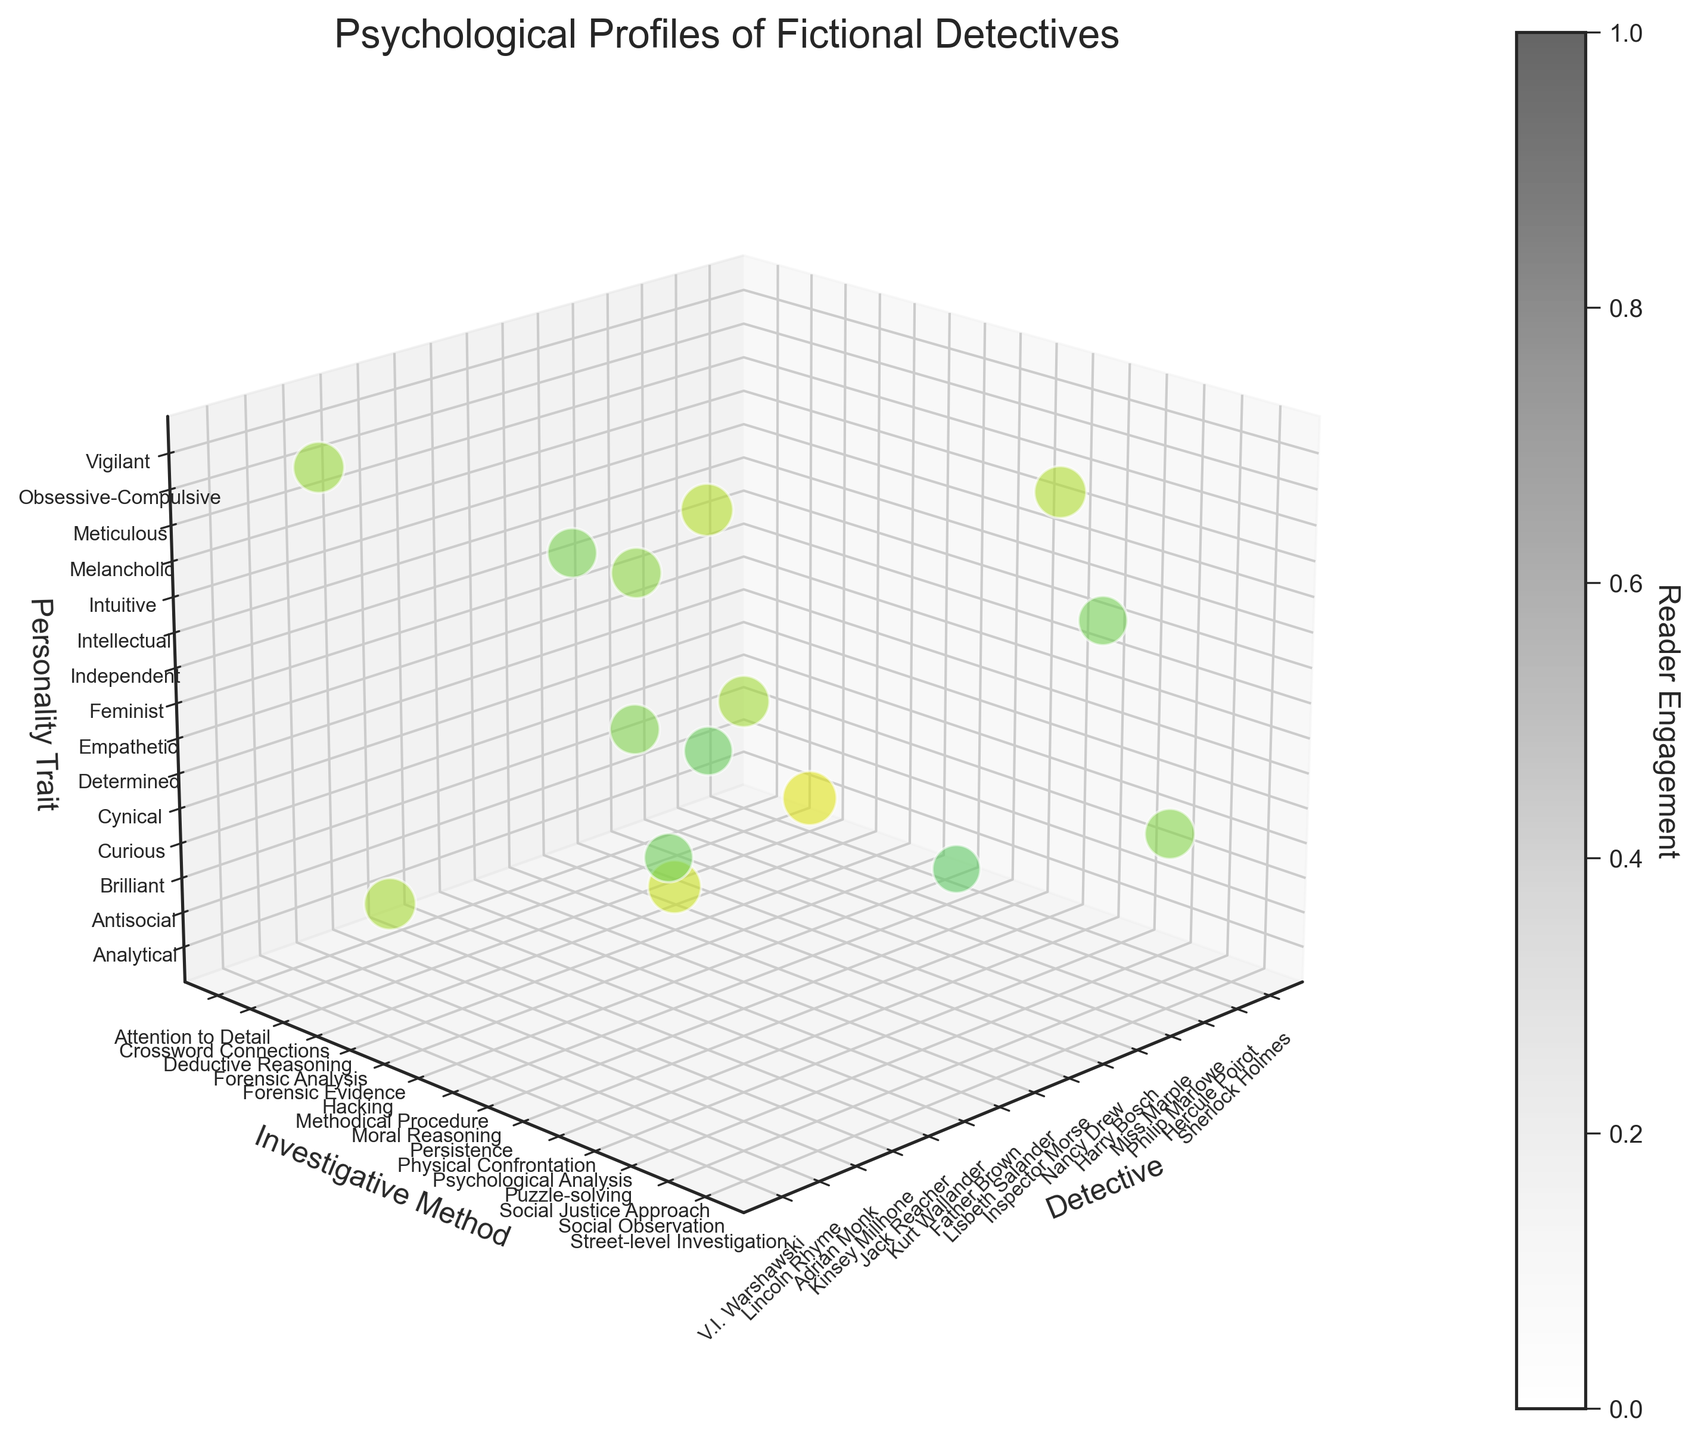What is the title of the chart? The title is typically displayed at the top of the chart, summarizing the content.
Answer: Psychological Profiles of Fictional Detectives Which detective appears to have the highest reader engagement? Look for the largest and most intense-colored bubble in the plot. This bubble represents Sherlock Holmes with a size that suggests high reader engagement (95).
Answer: Sherlock Holmes How are the personality traits represented on the chart? Observe the z-axis label, which indicates how personality traits are plotted upwards on the chart.
Answer: On the z-axis Which investigative method correlates with the highest reader engagement? Look for the y-axis category that aligns with the highest or most intense-colored bubble, which represents "Deductive Reasoning" used by Sherlock Holmes.
Answer: Deductive Reasoning What does each bubble's size represent? Each bubble's size varies and is directly proportional to reader engagement, as noted in the chart's legend or the size differences in bubbles.
Answer: Reader engagement Which detective has a similar reader engagement to Hercule Poirot? Compare bubbles of similar sizes, focusing on those around 88, and Inspector Morse with an engagement of 80 is closest.
Answer: Inspector Morse Which personality trait has the most detectives associated with it? Count the number of bubbles at each distinct z-axis level and find which level holds the most bubbles. Levels closest to the middle (around 79-83) seem to accumulate more.
Answer: Melancholic Who has the lowest reader engagement and what is their investigative method? Identify the smallest or less intense-colored bubble, representing Nancy Drew's reader engagement of 75 through "Puzzle-solving".
Answer: Nancy Drew, Puzzle-solving Are detectives utilizing forensic measures having higher than average reader engagement? Calculate the average engagement of the displayed detectives (~83.6) and compare it with those using forensic methods like Harry Bosch and Lincoln Rhyme, both above 85.
Answer: Yes Among Miss Marple, Father Brown, and Adrian Monk, who has the highest reader engagement? Compare the sizes of the bubbles representing these characters: Miss Marple (79), Father Brown (77), and Adrian Monk (85), where Adrian Monk's is largest.
Answer: Adrian Monk 